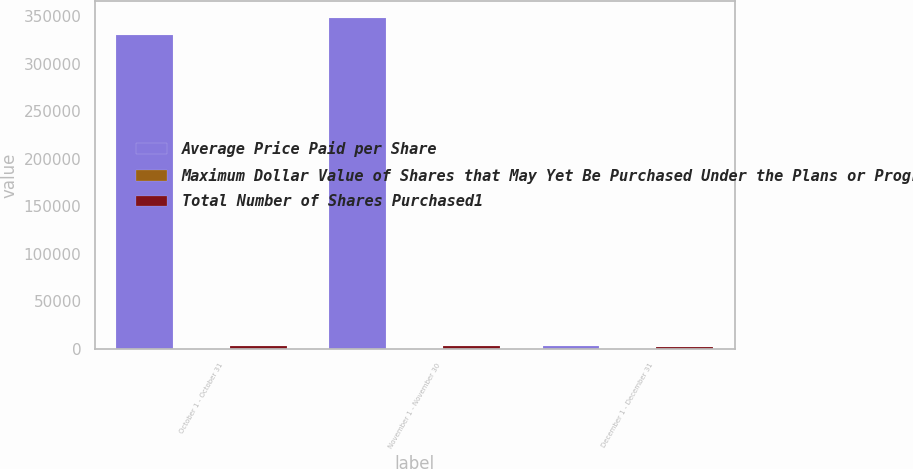Convert chart to OTSL. <chart><loc_0><loc_0><loc_500><loc_500><stacked_bar_chart><ecel><fcel>October 1 - October 31<fcel>November 1 - November 30<fcel>December 1 - December 31<nl><fcel>Average Price Paid per Share<fcel>330000<fcel>348400<fcel>2408<nl><fcel>Maximum Dollar Value of Shares that May Yet Be Purchased Under the Plans or Programs1 In millions<fcel>65.64<fcel>71.36<fcel>74.82<nl><fcel>Total Number of Shares Purchased1<fcel>2542<fcel>2517<fcel>2299<nl></chart> 